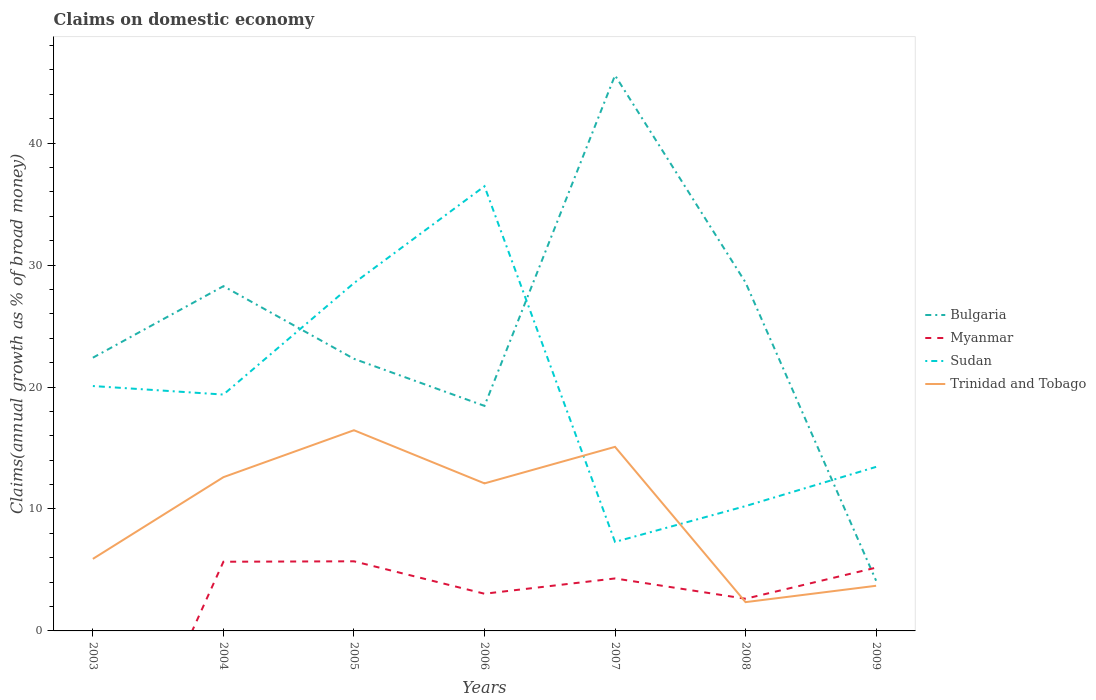Is the number of lines equal to the number of legend labels?
Provide a succinct answer. No. Across all years, what is the maximum percentage of broad money claimed on domestic economy in Bulgaria?
Your answer should be compact. 4.12. What is the total percentage of broad money claimed on domestic economy in Bulgaria in the graph?
Make the answer very short. 41.44. What is the difference between the highest and the second highest percentage of broad money claimed on domestic economy in Bulgaria?
Ensure brevity in your answer.  41.44. Is the percentage of broad money claimed on domestic economy in Sudan strictly greater than the percentage of broad money claimed on domestic economy in Myanmar over the years?
Your answer should be compact. No. How many lines are there?
Keep it short and to the point. 4. Does the graph contain any zero values?
Your answer should be compact. Yes. What is the title of the graph?
Provide a succinct answer. Claims on domestic economy. What is the label or title of the X-axis?
Provide a succinct answer. Years. What is the label or title of the Y-axis?
Offer a very short reply. Claims(annual growth as % of broad money). What is the Claims(annual growth as % of broad money) in Bulgaria in 2003?
Offer a terse response. 22.41. What is the Claims(annual growth as % of broad money) of Myanmar in 2003?
Make the answer very short. 0. What is the Claims(annual growth as % of broad money) of Sudan in 2003?
Your answer should be very brief. 20.08. What is the Claims(annual growth as % of broad money) of Trinidad and Tobago in 2003?
Keep it short and to the point. 5.91. What is the Claims(annual growth as % of broad money) in Bulgaria in 2004?
Ensure brevity in your answer.  28.27. What is the Claims(annual growth as % of broad money) of Myanmar in 2004?
Make the answer very short. 5.67. What is the Claims(annual growth as % of broad money) in Sudan in 2004?
Offer a terse response. 19.38. What is the Claims(annual growth as % of broad money) in Trinidad and Tobago in 2004?
Your answer should be compact. 12.61. What is the Claims(annual growth as % of broad money) in Bulgaria in 2005?
Your response must be concise. 22.32. What is the Claims(annual growth as % of broad money) of Myanmar in 2005?
Offer a terse response. 5.71. What is the Claims(annual growth as % of broad money) of Sudan in 2005?
Offer a very short reply. 28.52. What is the Claims(annual growth as % of broad money) of Trinidad and Tobago in 2005?
Your answer should be compact. 16.46. What is the Claims(annual growth as % of broad money) in Bulgaria in 2006?
Your response must be concise. 18.45. What is the Claims(annual growth as % of broad money) of Myanmar in 2006?
Provide a succinct answer. 3.05. What is the Claims(annual growth as % of broad money) in Sudan in 2006?
Provide a short and direct response. 36.47. What is the Claims(annual growth as % of broad money) of Trinidad and Tobago in 2006?
Offer a terse response. 12.1. What is the Claims(annual growth as % of broad money) of Bulgaria in 2007?
Offer a very short reply. 45.56. What is the Claims(annual growth as % of broad money) of Myanmar in 2007?
Ensure brevity in your answer.  4.3. What is the Claims(annual growth as % of broad money) of Sudan in 2007?
Give a very brief answer. 7.3. What is the Claims(annual growth as % of broad money) of Trinidad and Tobago in 2007?
Ensure brevity in your answer.  15.09. What is the Claims(annual growth as % of broad money) of Bulgaria in 2008?
Your answer should be very brief. 28.57. What is the Claims(annual growth as % of broad money) in Myanmar in 2008?
Your answer should be compact. 2.64. What is the Claims(annual growth as % of broad money) of Sudan in 2008?
Provide a short and direct response. 10.24. What is the Claims(annual growth as % of broad money) in Trinidad and Tobago in 2008?
Make the answer very short. 2.36. What is the Claims(annual growth as % of broad money) in Bulgaria in 2009?
Keep it short and to the point. 4.12. What is the Claims(annual growth as % of broad money) of Myanmar in 2009?
Provide a short and direct response. 5.19. What is the Claims(annual growth as % of broad money) in Sudan in 2009?
Make the answer very short. 13.45. What is the Claims(annual growth as % of broad money) of Trinidad and Tobago in 2009?
Ensure brevity in your answer.  3.7. Across all years, what is the maximum Claims(annual growth as % of broad money) in Bulgaria?
Your answer should be compact. 45.56. Across all years, what is the maximum Claims(annual growth as % of broad money) of Myanmar?
Offer a terse response. 5.71. Across all years, what is the maximum Claims(annual growth as % of broad money) of Sudan?
Your response must be concise. 36.47. Across all years, what is the maximum Claims(annual growth as % of broad money) in Trinidad and Tobago?
Give a very brief answer. 16.46. Across all years, what is the minimum Claims(annual growth as % of broad money) of Bulgaria?
Offer a terse response. 4.12. Across all years, what is the minimum Claims(annual growth as % of broad money) of Sudan?
Provide a succinct answer. 7.3. Across all years, what is the minimum Claims(annual growth as % of broad money) of Trinidad and Tobago?
Provide a short and direct response. 2.36. What is the total Claims(annual growth as % of broad money) in Bulgaria in the graph?
Ensure brevity in your answer.  169.7. What is the total Claims(annual growth as % of broad money) of Myanmar in the graph?
Provide a succinct answer. 26.56. What is the total Claims(annual growth as % of broad money) in Sudan in the graph?
Keep it short and to the point. 135.45. What is the total Claims(annual growth as % of broad money) of Trinidad and Tobago in the graph?
Your answer should be compact. 68.23. What is the difference between the Claims(annual growth as % of broad money) of Bulgaria in 2003 and that in 2004?
Offer a terse response. -5.87. What is the difference between the Claims(annual growth as % of broad money) of Sudan in 2003 and that in 2004?
Make the answer very short. 0.7. What is the difference between the Claims(annual growth as % of broad money) in Trinidad and Tobago in 2003 and that in 2004?
Provide a succinct answer. -6.7. What is the difference between the Claims(annual growth as % of broad money) in Bulgaria in 2003 and that in 2005?
Your answer should be compact. 0.09. What is the difference between the Claims(annual growth as % of broad money) in Sudan in 2003 and that in 2005?
Your answer should be very brief. -8.44. What is the difference between the Claims(annual growth as % of broad money) in Trinidad and Tobago in 2003 and that in 2005?
Ensure brevity in your answer.  -10.55. What is the difference between the Claims(annual growth as % of broad money) of Bulgaria in 2003 and that in 2006?
Keep it short and to the point. 3.95. What is the difference between the Claims(annual growth as % of broad money) of Sudan in 2003 and that in 2006?
Your answer should be compact. -16.38. What is the difference between the Claims(annual growth as % of broad money) of Trinidad and Tobago in 2003 and that in 2006?
Provide a succinct answer. -6.19. What is the difference between the Claims(annual growth as % of broad money) in Bulgaria in 2003 and that in 2007?
Offer a terse response. -23.15. What is the difference between the Claims(annual growth as % of broad money) of Sudan in 2003 and that in 2007?
Your answer should be very brief. 12.78. What is the difference between the Claims(annual growth as % of broad money) of Trinidad and Tobago in 2003 and that in 2007?
Offer a terse response. -9.19. What is the difference between the Claims(annual growth as % of broad money) of Bulgaria in 2003 and that in 2008?
Provide a short and direct response. -6.16. What is the difference between the Claims(annual growth as % of broad money) in Sudan in 2003 and that in 2008?
Offer a terse response. 9.84. What is the difference between the Claims(annual growth as % of broad money) of Trinidad and Tobago in 2003 and that in 2008?
Provide a succinct answer. 3.55. What is the difference between the Claims(annual growth as % of broad money) in Bulgaria in 2003 and that in 2009?
Make the answer very short. 18.29. What is the difference between the Claims(annual growth as % of broad money) of Sudan in 2003 and that in 2009?
Ensure brevity in your answer.  6.63. What is the difference between the Claims(annual growth as % of broad money) in Trinidad and Tobago in 2003 and that in 2009?
Keep it short and to the point. 2.2. What is the difference between the Claims(annual growth as % of broad money) of Bulgaria in 2004 and that in 2005?
Your answer should be compact. 5.96. What is the difference between the Claims(annual growth as % of broad money) of Myanmar in 2004 and that in 2005?
Provide a succinct answer. -0.04. What is the difference between the Claims(annual growth as % of broad money) of Sudan in 2004 and that in 2005?
Your answer should be compact. -9.14. What is the difference between the Claims(annual growth as % of broad money) in Trinidad and Tobago in 2004 and that in 2005?
Give a very brief answer. -3.85. What is the difference between the Claims(annual growth as % of broad money) in Bulgaria in 2004 and that in 2006?
Make the answer very short. 9.82. What is the difference between the Claims(annual growth as % of broad money) in Myanmar in 2004 and that in 2006?
Offer a terse response. 2.62. What is the difference between the Claims(annual growth as % of broad money) in Sudan in 2004 and that in 2006?
Your answer should be compact. -17.08. What is the difference between the Claims(annual growth as % of broad money) in Trinidad and Tobago in 2004 and that in 2006?
Your answer should be compact. 0.51. What is the difference between the Claims(annual growth as % of broad money) of Bulgaria in 2004 and that in 2007?
Provide a short and direct response. -17.29. What is the difference between the Claims(annual growth as % of broad money) in Myanmar in 2004 and that in 2007?
Provide a short and direct response. 1.37. What is the difference between the Claims(annual growth as % of broad money) of Sudan in 2004 and that in 2007?
Provide a succinct answer. 12.08. What is the difference between the Claims(annual growth as % of broad money) in Trinidad and Tobago in 2004 and that in 2007?
Offer a very short reply. -2.49. What is the difference between the Claims(annual growth as % of broad money) in Bulgaria in 2004 and that in 2008?
Offer a terse response. -0.3. What is the difference between the Claims(annual growth as % of broad money) in Myanmar in 2004 and that in 2008?
Ensure brevity in your answer.  3.03. What is the difference between the Claims(annual growth as % of broad money) of Sudan in 2004 and that in 2008?
Offer a very short reply. 9.15. What is the difference between the Claims(annual growth as % of broad money) of Trinidad and Tobago in 2004 and that in 2008?
Provide a succinct answer. 10.25. What is the difference between the Claims(annual growth as % of broad money) of Bulgaria in 2004 and that in 2009?
Offer a very short reply. 24.15. What is the difference between the Claims(annual growth as % of broad money) in Myanmar in 2004 and that in 2009?
Provide a short and direct response. 0.48. What is the difference between the Claims(annual growth as % of broad money) in Sudan in 2004 and that in 2009?
Provide a succinct answer. 5.93. What is the difference between the Claims(annual growth as % of broad money) in Trinidad and Tobago in 2004 and that in 2009?
Offer a terse response. 8.91. What is the difference between the Claims(annual growth as % of broad money) in Bulgaria in 2005 and that in 2006?
Your answer should be compact. 3.86. What is the difference between the Claims(annual growth as % of broad money) in Myanmar in 2005 and that in 2006?
Offer a terse response. 2.66. What is the difference between the Claims(annual growth as % of broad money) in Sudan in 2005 and that in 2006?
Give a very brief answer. -7.94. What is the difference between the Claims(annual growth as % of broad money) of Trinidad and Tobago in 2005 and that in 2006?
Your response must be concise. 4.36. What is the difference between the Claims(annual growth as % of broad money) in Bulgaria in 2005 and that in 2007?
Provide a short and direct response. -23.24. What is the difference between the Claims(annual growth as % of broad money) in Myanmar in 2005 and that in 2007?
Ensure brevity in your answer.  1.41. What is the difference between the Claims(annual growth as % of broad money) of Sudan in 2005 and that in 2007?
Ensure brevity in your answer.  21.23. What is the difference between the Claims(annual growth as % of broad money) in Trinidad and Tobago in 2005 and that in 2007?
Make the answer very short. 1.36. What is the difference between the Claims(annual growth as % of broad money) of Bulgaria in 2005 and that in 2008?
Offer a very short reply. -6.26. What is the difference between the Claims(annual growth as % of broad money) of Myanmar in 2005 and that in 2008?
Provide a short and direct response. 3.07. What is the difference between the Claims(annual growth as % of broad money) in Sudan in 2005 and that in 2008?
Offer a terse response. 18.29. What is the difference between the Claims(annual growth as % of broad money) in Trinidad and Tobago in 2005 and that in 2008?
Offer a very short reply. 14.1. What is the difference between the Claims(annual growth as % of broad money) in Bulgaria in 2005 and that in 2009?
Ensure brevity in your answer.  18.2. What is the difference between the Claims(annual growth as % of broad money) of Myanmar in 2005 and that in 2009?
Your answer should be compact. 0.52. What is the difference between the Claims(annual growth as % of broad money) in Sudan in 2005 and that in 2009?
Make the answer very short. 15.07. What is the difference between the Claims(annual growth as % of broad money) in Trinidad and Tobago in 2005 and that in 2009?
Your answer should be very brief. 12.75. What is the difference between the Claims(annual growth as % of broad money) of Bulgaria in 2006 and that in 2007?
Your answer should be compact. -27.11. What is the difference between the Claims(annual growth as % of broad money) of Myanmar in 2006 and that in 2007?
Provide a short and direct response. -1.25. What is the difference between the Claims(annual growth as % of broad money) of Sudan in 2006 and that in 2007?
Your response must be concise. 29.17. What is the difference between the Claims(annual growth as % of broad money) of Trinidad and Tobago in 2006 and that in 2007?
Provide a short and direct response. -3. What is the difference between the Claims(annual growth as % of broad money) in Bulgaria in 2006 and that in 2008?
Keep it short and to the point. -10.12. What is the difference between the Claims(annual growth as % of broad money) in Myanmar in 2006 and that in 2008?
Keep it short and to the point. 0.41. What is the difference between the Claims(annual growth as % of broad money) in Sudan in 2006 and that in 2008?
Offer a terse response. 26.23. What is the difference between the Claims(annual growth as % of broad money) in Trinidad and Tobago in 2006 and that in 2008?
Your answer should be compact. 9.74. What is the difference between the Claims(annual growth as % of broad money) in Bulgaria in 2006 and that in 2009?
Your response must be concise. 14.33. What is the difference between the Claims(annual growth as % of broad money) in Myanmar in 2006 and that in 2009?
Your response must be concise. -2.14. What is the difference between the Claims(annual growth as % of broad money) in Sudan in 2006 and that in 2009?
Your response must be concise. 23.01. What is the difference between the Claims(annual growth as % of broad money) of Trinidad and Tobago in 2006 and that in 2009?
Provide a short and direct response. 8.4. What is the difference between the Claims(annual growth as % of broad money) in Bulgaria in 2007 and that in 2008?
Offer a terse response. 16.99. What is the difference between the Claims(annual growth as % of broad money) in Myanmar in 2007 and that in 2008?
Your answer should be very brief. 1.66. What is the difference between the Claims(annual growth as % of broad money) of Sudan in 2007 and that in 2008?
Keep it short and to the point. -2.94. What is the difference between the Claims(annual growth as % of broad money) of Trinidad and Tobago in 2007 and that in 2008?
Keep it short and to the point. 12.73. What is the difference between the Claims(annual growth as % of broad money) in Bulgaria in 2007 and that in 2009?
Give a very brief answer. 41.44. What is the difference between the Claims(annual growth as % of broad money) of Myanmar in 2007 and that in 2009?
Your answer should be compact. -0.89. What is the difference between the Claims(annual growth as % of broad money) of Sudan in 2007 and that in 2009?
Give a very brief answer. -6.15. What is the difference between the Claims(annual growth as % of broad money) of Trinidad and Tobago in 2007 and that in 2009?
Your answer should be very brief. 11.39. What is the difference between the Claims(annual growth as % of broad money) of Bulgaria in 2008 and that in 2009?
Your response must be concise. 24.45. What is the difference between the Claims(annual growth as % of broad money) of Myanmar in 2008 and that in 2009?
Offer a very short reply. -2.55. What is the difference between the Claims(annual growth as % of broad money) of Sudan in 2008 and that in 2009?
Provide a short and direct response. -3.22. What is the difference between the Claims(annual growth as % of broad money) of Trinidad and Tobago in 2008 and that in 2009?
Offer a very short reply. -1.34. What is the difference between the Claims(annual growth as % of broad money) in Bulgaria in 2003 and the Claims(annual growth as % of broad money) in Myanmar in 2004?
Your answer should be very brief. 16.73. What is the difference between the Claims(annual growth as % of broad money) in Bulgaria in 2003 and the Claims(annual growth as % of broad money) in Sudan in 2004?
Make the answer very short. 3.02. What is the difference between the Claims(annual growth as % of broad money) in Bulgaria in 2003 and the Claims(annual growth as % of broad money) in Trinidad and Tobago in 2004?
Your response must be concise. 9.8. What is the difference between the Claims(annual growth as % of broad money) in Sudan in 2003 and the Claims(annual growth as % of broad money) in Trinidad and Tobago in 2004?
Your answer should be very brief. 7.47. What is the difference between the Claims(annual growth as % of broad money) in Bulgaria in 2003 and the Claims(annual growth as % of broad money) in Myanmar in 2005?
Provide a short and direct response. 16.7. What is the difference between the Claims(annual growth as % of broad money) of Bulgaria in 2003 and the Claims(annual growth as % of broad money) of Sudan in 2005?
Offer a very short reply. -6.12. What is the difference between the Claims(annual growth as % of broad money) in Bulgaria in 2003 and the Claims(annual growth as % of broad money) in Trinidad and Tobago in 2005?
Provide a short and direct response. 5.95. What is the difference between the Claims(annual growth as % of broad money) of Sudan in 2003 and the Claims(annual growth as % of broad money) of Trinidad and Tobago in 2005?
Your answer should be very brief. 3.62. What is the difference between the Claims(annual growth as % of broad money) in Bulgaria in 2003 and the Claims(annual growth as % of broad money) in Myanmar in 2006?
Make the answer very short. 19.36. What is the difference between the Claims(annual growth as % of broad money) in Bulgaria in 2003 and the Claims(annual growth as % of broad money) in Sudan in 2006?
Keep it short and to the point. -14.06. What is the difference between the Claims(annual growth as % of broad money) of Bulgaria in 2003 and the Claims(annual growth as % of broad money) of Trinidad and Tobago in 2006?
Your answer should be compact. 10.31. What is the difference between the Claims(annual growth as % of broad money) of Sudan in 2003 and the Claims(annual growth as % of broad money) of Trinidad and Tobago in 2006?
Your answer should be very brief. 7.98. What is the difference between the Claims(annual growth as % of broad money) of Bulgaria in 2003 and the Claims(annual growth as % of broad money) of Myanmar in 2007?
Give a very brief answer. 18.1. What is the difference between the Claims(annual growth as % of broad money) of Bulgaria in 2003 and the Claims(annual growth as % of broad money) of Sudan in 2007?
Offer a terse response. 15.11. What is the difference between the Claims(annual growth as % of broad money) of Bulgaria in 2003 and the Claims(annual growth as % of broad money) of Trinidad and Tobago in 2007?
Ensure brevity in your answer.  7.31. What is the difference between the Claims(annual growth as % of broad money) of Sudan in 2003 and the Claims(annual growth as % of broad money) of Trinidad and Tobago in 2007?
Provide a succinct answer. 4.99. What is the difference between the Claims(annual growth as % of broad money) of Bulgaria in 2003 and the Claims(annual growth as % of broad money) of Myanmar in 2008?
Give a very brief answer. 19.77. What is the difference between the Claims(annual growth as % of broad money) of Bulgaria in 2003 and the Claims(annual growth as % of broad money) of Sudan in 2008?
Keep it short and to the point. 12.17. What is the difference between the Claims(annual growth as % of broad money) in Bulgaria in 2003 and the Claims(annual growth as % of broad money) in Trinidad and Tobago in 2008?
Ensure brevity in your answer.  20.05. What is the difference between the Claims(annual growth as % of broad money) of Sudan in 2003 and the Claims(annual growth as % of broad money) of Trinidad and Tobago in 2008?
Offer a very short reply. 17.72. What is the difference between the Claims(annual growth as % of broad money) in Bulgaria in 2003 and the Claims(annual growth as % of broad money) in Myanmar in 2009?
Your response must be concise. 17.22. What is the difference between the Claims(annual growth as % of broad money) of Bulgaria in 2003 and the Claims(annual growth as % of broad money) of Sudan in 2009?
Ensure brevity in your answer.  8.95. What is the difference between the Claims(annual growth as % of broad money) of Bulgaria in 2003 and the Claims(annual growth as % of broad money) of Trinidad and Tobago in 2009?
Your answer should be very brief. 18.7. What is the difference between the Claims(annual growth as % of broad money) of Sudan in 2003 and the Claims(annual growth as % of broad money) of Trinidad and Tobago in 2009?
Give a very brief answer. 16.38. What is the difference between the Claims(annual growth as % of broad money) of Bulgaria in 2004 and the Claims(annual growth as % of broad money) of Myanmar in 2005?
Your response must be concise. 22.56. What is the difference between the Claims(annual growth as % of broad money) of Bulgaria in 2004 and the Claims(annual growth as % of broad money) of Sudan in 2005?
Provide a short and direct response. -0.25. What is the difference between the Claims(annual growth as % of broad money) of Bulgaria in 2004 and the Claims(annual growth as % of broad money) of Trinidad and Tobago in 2005?
Offer a terse response. 11.81. What is the difference between the Claims(annual growth as % of broad money) in Myanmar in 2004 and the Claims(annual growth as % of broad money) in Sudan in 2005?
Your response must be concise. -22.85. What is the difference between the Claims(annual growth as % of broad money) in Myanmar in 2004 and the Claims(annual growth as % of broad money) in Trinidad and Tobago in 2005?
Offer a terse response. -10.78. What is the difference between the Claims(annual growth as % of broad money) of Sudan in 2004 and the Claims(annual growth as % of broad money) of Trinidad and Tobago in 2005?
Offer a very short reply. 2.93. What is the difference between the Claims(annual growth as % of broad money) in Bulgaria in 2004 and the Claims(annual growth as % of broad money) in Myanmar in 2006?
Give a very brief answer. 25.22. What is the difference between the Claims(annual growth as % of broad money) in Bulgaria in 2004 and the Claims(annual growth as % of broad money) in Sudan in 2006?
Make the answer very short. -8.19. What is the difference between the Claims(annual growth as % of broad money) in Bulgaria in 2004 and the Claims(annual growth as % of broad money) in Trinidad and Tobago in 2006?
Give a very brief answer. 16.17. What is the difference between the Claims(annual growth as % of broad money) of Myanmar in 2004 and the Claims(annual growth as % of broad money) of Sudan in 2006?
Give a very brief answer. -30.79. What is the difference between the Claims(annual growth as % of broad money) in Myanmar in 2004 and the Claims(annual growth as % of broad money) in Trinidad and Tobago in 2006?
Provide a succinct answer. -6.43. What is the difference between the Claims(annual growth as % of broad money) in Sudan in 2004 and the Claims(annual growth as % of broad money) in Trinidad and Tobago in 2006?
Ensure brevity in your answer.  7.28. What is the difference between the Claims(annual growth as % of broad money) of Bulgaria in 2004 and the Claims(annual growth as % of broad money) of Myanmar in 2007?
Provide a succinct answer. 23.97. What is the difference between the Claims(annual growth as % of broad money) in Bulgaria in 2004 and the Claims(annual growth as % of broad money) in Sudan in 2007?
Your answer should be very brief. 20.97. What is the difference between the Claims(annual growth as % of broad money) in Bulgaria in 2004 and the Claims(annual growth as % of broad money) in Trinidad and Tobago in 2007?
Give a very brief answer. 13.18. What is the difference between the Claims(annual growth as % of broad money) in Myanmar in 2004 and the Claims(annual growth as % of broad money) in Sudan in 2007?
Give a very brief answer. -1.63. What is the difference between the Claims(annual growth as % of broad money) in Myanmar in 2004 and the Claims(annual growth as % of broad money) in Trinidad and Tobago in 2007?
Provide a succinct answer. -9.42. What is the difference between the Claims(annual growth as % of broad money) in Sudan in 2004 and the Claims(annual growth as % of broad money) in Trinidad and Tobago in 2007?
Give a very brief answer. 4.29. What is the difference between the Claims(annual growth as % of broad money) of Bulgaria in 2004 and the Claims(annual growth as % of broad money) of Myanmar in 2008?
Give a very brief answer. 25.63. What is the difference between the Claims(annual growth as % of broad money) in Bulgaria in 2004 and the Claims(annual growth as % of broad money) in Sudan in 2008?
Offer a terse response. 18.03. What is the difference between the Claims(annual growth as % of broad money) of Bulgaria in 2004 and the Claims(annual growth as % of broad money) of Trinidad and Tobago in 2008?
Offer a very short reply. 25.91. What is the difference between the Claims(annual growth as % of broad money) in Myanmar in 2004 and the Claims(annual growth as % of broad money) in Sudan in 2008?
Your answer should be very brief. -4.56. What is the difference between the Claims(annual growth as % of broad money) of Myanmar in 2004 and the Claims(annual growth as % of broad money) of Trinidad and Tobago in 2008?
Ensure brevity in your answer.  3.31. What is the difference between the Claims(annual growth as % of broad money) in Sudan in 2004 and the Claims(annual growth as % of broad money) in Trinidad and Tobago in 2008?
Your answer should be very brief. 17.02. What is the difference between the Claims(annual growth as % of broad money) in Bulgaria in 2004 and the Claims(annual growth as % of broad money) in Myanmar in 2009?
Ensure brevity in your answer.  23.08. What is the difference between the Claims(annual growth as % of broad money) of Bulgaria in 2004 and the Claims(annual growth as % of broad money) of Sudan in 2009?
Ensure brevity in your answer.  14.82. What is the difference between the Claims(annual growth as % of broad money) in Bulgaria in 2004 and the Claims(annual growth as % of broad money) in Trinidad and Tobago in 2009?
Make the answer very short. 24.57. What is the difference between the Claims(annual growth as % of broad money) in Myanmar in 2004 and the Claims(annual growth as % of broad money) in Sudan in 2009?
Offer a very short reply. -7.78. What is the difference between the Claims(annual growth as % of broad money) in Myanmar in 2004 and the Claims(annual growth as % of broad money) in Trinidad and Tobago in 2009?
Ensure brevity in your answer.  1.97. What is the difference between the Claims(annual growth as % of broad money) in Sudan in 2004 and the Claims(annual growth as % of broad money) in Trinidad and Tobago in 2009?
Your answer should be very brief. 15.68. What is the difference between the Claims(annual growth as % of broad money) of Bulgaria in 2005 and the Claims(annual growth as % of broad money) of Myanmar in 2006?
Provide a succinct answer. 19.27. What is the difference between the Claims(annual growth as % of broad money) in Bulgaria in 2005 and the Claims(annual growth as % of broad money) in Sudan in 2006?
Provide a succinct answer. -14.15. What is the difference between the Claims(annual growth as % of broad money) in Bulgaria in 2005 and the Claims(annual growth as % of broad money) in Trinidad and Tobago in 2006?
Provide a succinct answer. 10.22. What is the difference between the Claims(annual growth as % of broad money) of Myanmar in 2005 and the Claims(annual growth as % of broad money) of Sudan in 2006?
Offer a very short reply. -30.76. What is the difference between the Claims(annual growth as % of broad money) of Myanmar in 2005 and the Claims(annual growth as % of broad money) of Trinidad and Tobago in 2006?
Give a very brief answer. -6.39. What is the difference between the Claims(annual growth as % of broad money) in Sudan in 2005 and the Claims(annual growth as % of broad money) in Trinidad and Tobago in 2006?
Provide a succinct answer. 16.43. What is the difference between the Claims(annual growth as % of broad money) in Bulgaria in 2005 and the Claims(annual growth as % of broad money) in Myanmar in 2007?
Give a very brief answer. 18.01. What is the difference between the Claims(annual growth as % of broad money) of Bulgaria in 2005 and the Claims(annual growth as % of broad money) of Sudan in 2007?
Your answer should be very brief. 15.02. What is the difference between the Claims(annual growth as % of broad money) in Bulgaria in 2005 and the Claims(annual growth as % of broad money) in Trinidad and Tobago in 2007?
Your response must be concise. 7.22. What is the difference between the Claims(annual growth as % of broad money) of Myanmar in 2005 and the Claims(annual growth as % of broad money) of Sudan in 2007?
Offer a terse response. -1.59. What is the difference between the Claims(annual growth as % of broad money) in Myanmar in 2005 and the Claims(annual growth as % of broad money) in Trinidad and Tobago in 2007?
Give a very brief answer. -9.39. What is the difference between the Claims(annual growth as % of broad money) in Sudan in 2005 and the Claims(annual growth as % of broad money) in Trinidad and Tobago in 2007?
Your answer should be very brief. 13.43. What is the difference between the Claims(annual growth as % of broad money) of Bulgaria in 2005 and the Claims(annual growth as % of broad money) of Myanmar in 2008?
Offer a terse response. 19.68. What is the difference between the Claims(annual growth as % of broad money) of Bulgaria in 2005 and the Claims(annual growth as % of broad money) of Sudan in 2008?
Offer a terse response. 12.08. What is the difference between the Claims(annual growth as % of broad money) of Bulgaria in 2005 and the Claims(annual growth as % of broad money) of Trinidad and Tobago in 2008?
Your answer should be compact. 19.95. What is the difference between the Claims(annual growth as % of broad money) in Myanmar in 2005 and the Claims(annual growth as % of broad money) in Sudan in 2008?
Offer a terse response. -4.53. What is the difference between the Claims(annual growth as % of broad money) of Myanmar in 2005 and the Claims(annual growth as % of broad money) of Trinidad and Tobago in 2008?
Provide a succinct answer. 3.35. What is the difference between the Claims(annual growth as % of broad money) in Sudan in 2005 and the Claims(annual growth as % of broad money) in Trinidad and Tobago in 2008?
Your answer should be very brief. 26.16. What is the difference between the Claims(annual growth as % of broad money) of Bulgaria in 2005 and the Claims(annual growth as % of broad money) of Myanmar in 2009?
Your answer should be compact. 17.13. What is the difference between the Claims(annual growth as % of broad money) in Bulgaria in 2005 and the Claims(annual growth as % of broad money) in Sudan in 2009?
Your answer should be very brief. 8.86. What is the difference between the Claims(annual growth as % of broad money) of Bulgaria in 2005 and the Claims(annual growth as % of broad money) of Trinidad and Tobago in 2009?
Keep it short and to the point. 18.61. What is the difference between the Claims(annual growth as % of broad money) of Myanmar in 2005 and the Claims(annual growth as % of broad money) of Sudan in 2009?
Give a very brief answer. -7.74. What is the difference between the Claims(annual growth as % of broad money) in Myanmar in 2005 and the Claims(annual growth as % of broad money) in Trinidad and Tobago in 2009?
Give a very brief answer. 2.01. What is the difference between the Claims(annual growth as % of broad money) of Sudan in 2005 and the Claims(annual growth as % of broad money) of Trinidad and Tobago in 2009?
Offer a terse response. 24.82. What is the difference between the Claims(annual growth as % of broad money) in Bulgaria in 2006 and the Claims(annual growth as % of broad money) in Myanmar in 2007?
Your answer should be compact. 14.15. What is the difference between the Claims(annual growth as % of broad money) of Bulgaria in 2006 and the Claims(annual growth as % of broad money) of Sudan in 2007?
Provide a short and direct response. 11.15. What is the difference between the Claims(annual growth as % of broad money) in Bulgaria in 2006 and the Claims(annual growth as % of broad money) in Trinidad and Tobago in 2007?
Offer a very short reply. 3.36. What is the difference between the Claims(annual growth as % of broad money) of Myanmar in 2006 and the Claims(annual growth as % of broad money) of Sudan in 2007?
Keep it short and to the point. -4.25. What is the difference between the Claims(annual growth as % of broad money) in Myanmar in 2006 and the Claims(annual growth as % of broad money) in Trinidad and Tobago in 2007?
Ensure brevity in your answer.  -12.04. What is the difference between the Claims(annual growth as % of broad money) in Sudan in 2006 and the Claims(annual growth as % of broad money) in Trinidad and Tobago in 2007?
Your answer should be very brief. 21.37. What is the difference between the Claims(annual growth as % of broad money) in Bulgaria in 2006 and the Claims(annual growth as % of broad money) in Myanmar in 2008?
Offer a very short reply. 15.81. What is the difference between the Claims(annual growth as % of broad money) of Bulgaria in 2006 and the Claims(annual growth as % of broad money) of Sudan in 2008?
Keep it short and to the point. 8.22. What is the difference between the Claims(annual growth as % of broad money) in Bulgaria in 2006 and the Claims(annual growth as % of broad money) in Trinidad and Tobago in 2008?
Provide a succinct answer. 16.09. What is the difference between the Claims(annual growth as % of broad money) of Myanmar in 2006 and the Claims(annual growth as % of broad money) of Sudan in 2008?
Make the answer very short. -7.19. What is the difference between the Claims(annual growth as % of broad money) in Myanmar in 2006 and the Claims(annual growth as % of broad money) in Trinidad and Tobago in 2008?
Offer a terse response. 0.69. What is the difference between the Claims(annual growth as % of broad money) of Sudan in 2006 and the Claims(annual growth as % of broad money) of Trinidad and Tobago in 2008?
Your answer should be compact. 34.11. What is the difference between the Claims(annual growth as % of broad money) in Bulgaria in 2006 and the Claims(annual growth as % of broad money) in Myanmar in 2009?
Provide a succinct answer. 13.27. What is the difference between the Claims(annual growth as % of broad money) of Bulgaria in 2006 and the Claims(annual growth as % of broad money) of Sudan in 2009?
Offer a very short reply. 5. What is the difference between the Claims(annual growth as % of broad money) of Bulgaria in 2006 and the Claims(annual growth as % of broad money) of Trinidad and Tobago in 2009?
Keep it short and to the point. 14.75. What is the difference between the Claims(annual growth as % of broad money) in Myanmar in 2006 and the Claims(annual growth as % of broad money) in Sudan in 2009?
Give a very brief answer. -10.4. What is the difference between the Claims(annual growth as % of broad money) in Myanmar in 2006 and the Claims(annual growth as % of broad money) in Trinidad and Tobago in 2009?
Keep it short and to the point. -0.65. What is the difference between the Claims(annual growth as % of broad money) in Sudan in 2006 and the Claims(annual growth as % of broad money) in Trinidad and Tobago in 2009?
Your response must be concise. 32.76. What is the difference between the Claims(annual growth as % of broad money) of Bulgaria in 2007 and the Claims(annual growth as % of broad money) of Myanmar in 2008?
Make the answer very short. 42.92. What is the difference between the Claims(annual growth as % of broad money) in Bulgaria in 2007 and the Claims(annual growth as % of broad money) in Sudan in 2008?
Ensure brevity in your answer.  35.32. What is the difference between the Claims(annual growth as % of broad money) of Bulgaria in 2007 and the Claims(annual growth as % of broad money) of Trinidad and Tobago in 2008?
Provide a succinct answer. 43.2. What is the difference between the Claims(annual growth as % of broad money) of Myanmar in 2007 and the Claims(annual growth as % of broad money) of Sudan in 2008?
Your answer should be compact. -5.93. What is the difference between the Claims(annual growth as % of broad money) of Myanmar in 2007 and the Claims(annual growth as % of broad money) of Trinidad and Tobago in 2008?
Provide a succinct answer. 1.94. What is the difference between the Claims(annual growth as % of broad money) in Sudan in 2007 and the Claims(annual growth as % of broad money) in Trinidad and Tobago in 2008?
Keep it short and to the point. 4.94. What is the difference between the Claims(annual growth as % of broad money) of Bulgaria in 2007 and the Claims(annual growth as % of broad money) of Myanmar in 2009?
Provide a succinct answer. 40.37. What is the difference between the Claims(annual growth as % of broad money) of Bulgaria in 2007 and the Claims(annual growth as % of broad money) of Sudan in 2009?
Give a very brief answer. 32.11. What is the difference between the Claims(annual growth as % of broad money) in Bulgaria in 2007 and the Claims(annual growth as % of broad money) in Trinidad and Tobago in 2009?
Your answer should be very brief. 41.86. What is the difference between the Claims(annual growth as % of broad money) of Myanmar in 2007 and the Claims(annual growth as % of broad money) of Sudan in 2009?
Ensure brevity in your answer.  -9.15. What is the difference between the Claims(annual growth as % of broad money) in Myanmar in 2007 and the Claims(annual growth as % of broad money) in Trinidad and Tobago in 2009?
Your answer should be compact. 0.6. What is the difference between the Claims(annual growth as % of broad money) in Sudan in 2007 and the Claims(annual growth as % of broad money) in Trinidad and Tobago in 2009?
Offer a very short reply. 3.6. What is the difference between the Claims(annual growth as % of broad money) of Bulgaria in 2008 and the Claims(annual growth as % of broad money) of Myanmar in 2009?
Make the answer very short. 23.38. What is the difference between the Claims(annual growth as % of broad money) of Bulgaria in 2008 and the Claims(annual growth as % of broad money) of Sudan in 2009?
Give a very brief answer. 15.12. What is the difference between the Claims(annual growth as % of broad money) of Bulgaria in 2008 and the Claims(annual growth as % of broad money) of Trinidad and Tobago in 2009?
Make the answer very short. 24.87. What is the difference between the Claims(annual growth as % of broad money) in Myanmar in 2008 and the Claims(annual growth as % of broad money) in Sudan in 2009?
Give a very brief answer. -10.81. What is the difference between the Claims(annual growth as % of broad money) of Myanmar in 2008 and the Claims(annual growth as % of broad money) of Trinidad and Tobago in 2009?
Your answer should be very brief. -1.06. What is the difference between the Claims(annual growth as % of broad money) in Sudan in 2008 and the Claims(annual growth as % of broad money) in Trinidad and Tobago in 2009?
Your answer should be compact. 6.53. What is the average Claims(annual growth as % of broad money) in Bulgaria per year?
Your response must be concise. 24.24. What is the average Claims(annual growth as % of broad money) of Myanmar per year?
Offer a very short reply. 3.79. What is the average Claims(annual growth as % of broad money) in Sudan per year?
Your answer should be very brief. 19.35. What is the average Claims(annual growth as % of broad money) of Trinidad and Tobago per year?
Offer a terse response. 9.75. In the year 2003, what is the difference between the Claims(annual growth as % of broad money) in Bulgaria and Claims(annual growth as % of broad money) in Sudan?
Your response must be concise. 2.32. In the year 2003, what is the difference between the Claims(annual growth as % of broad money) in Bulgaria and Claims(annual growth as % of broad money) in Trinidad and Tobago?
Your answer should be compact. 16.5. In the year 2003, what is the difference between the Claims(annual growth as % of broad money) in Sudan and Claims(annual growth as % of broad money) in Trinidad and Tobago?
Offer a terse response. 14.17. In the year 2004, what is the difference between the Claims(annual growth as % of broad money) of Bulgaria and Claims(annual growth as % of broad money) of Myanmar?
Give a very brief answer. 22.6. In the year 2004, what is the difference between the Claims(annual growth as % of broad money) of Bulgaria and Claims(annual growth as % of broad money) of Sudan?
Offer a very short reply. 8.89. In the year 2004, what is the difference between the Claims(annual growth as % of broad money) of Bulgaria and Claims(annual growth as % of broad money) of Trinidad and Tobago?
Make the answer very short. 15.66. In the year 2004, what is the difference between the Claims(annual growth as % of broad money) of Myanmar and Claims(annual growth as % of broad money) of Sudan?
Provide a short and direct response. -13.71. In the year 2004, what is the difference between the Claims(annual growth as % of broad money) in Myanmar and Claims(annual growth as % of broad money) in Trinidad and Tobago?
Your response must be concise. -6.93. In the year 2004, what is the difference between the Claims(annual growth as % of broad money) in Sudan and Claims(annual growth as % of broad money) in Trinidad and Tobago?
Provide a succinct answer. 6.77. In the year 2005, what is the difference between the Claims(annual growth as % of broad money) of Bulgaria and Claims(annual growth as % of broad money) of Myanmar?
Offer a terse response. 16.61. In the year 2005, what is the difference between the Claims(annual growth as % of broad money) of Bulgaria and Claims(annual growth as % of broad money) of Sudan?
Offer a terse response. -6.21. In the year 2005, what is the difference between the Claims(annual growth as % of broad money) in Bulgaria and Claims(annual growth as % of broad money) in Trinidad and Tobago?
Your answer should be compact. 5.86. In the year 2005, what is the difference between the Claims(annual growth as % of broad money) in Myanmar and Claims(annual growth as % of broad money) in Sudan?
Ensure brevity in your answer.  -22.82. In the year 2005, what is the difference between the Claims(annual growth as % of broad money) of Myanmar and Claims(annual growth as % of broad money) of Trinidad and Tobago?
Offer a very short reply. -10.75. In the year 2005, what is the difference between the Claims(annual growth as % of broad money) of Sudan and Claims(annual growth as % of broad money) of Trinidad and Tobago?
Offer a terse response. 12.07. In the year 2006, what is the difference between the Claims(annual growth as % of broad money) of Bulgaria and Claims(annual growth as % of broad money) of Myanmar?
Your answer should be compact. 15.4. In the year 2006, what is the difference between the Claims(annual growth as % of broad money) of Bulgaria and Claims(annual growth as % of broad money) of Sudan?
Provide a short and direct response. -18.01. In the year 2006, what is the difference between the Claims(annual growth as % of broad money) in Bulgaria and Claims(annual growth as % of broad money) in Trinidad and Tobago?
Your response must be concise. 6.36. In the year 2006, what is the difference between the Claims(annual growth as % of broad money) of Myanmar and Claims(annual growth as % of broad money) of Sudan?
Ensure brevity in your answer.  -33.42. In the year 2006, what is the difference between the Claims(annual growth as % of broad money) of Myanmar and Claims(annual growth as % of broad money) of Trinidad and Tobago?
Keep it short and to the point. -9.05. In the year 2006, what is the difference between the Claims(annual growth as % of broad money) of Sudan and Claims(annual growth as % of broad money) of Trinidad and Tobago?
Give a very brief answer. 24.37. In the year 2007, what is the difference between the Claims(annual growth as % of broad money) of Bulgaria and Claims(annual growth as % of broad money) of Myanmar?
Your response must be concise. 41.26. In the year 2007, what is the difference between the Claims(annual growth as % of broad money) of Bulgaria and Claims(annual growth as % of broad money) of Sudan?
Your response must be concise. 38.26. In the year 2007, what is the difference between the Claims(annual growth as % of broad money) of Bulgaria and Claims(annual growth as % of broad money) of Trinidad and Tobago?
Make the answer very short. 30.46. In the year 2007, what is the difference between the Claims(annual growth as % of broad money) of Myanmar and Claims(annual growth as % of broad money) of Sudan?
Provide a short and direct response. -3. In the year 2007, what is the difference between the Claims(annual growth as % of broad money) of Myanmar and Claims(annual growth as % of broad money) of Trinidad and Tobago?
Provide a succinct answer. -10.79. In the year 2007, what is the difference between the Claims(annual growth as % of broad money) in Sudan and Claims(annual growth as % of broad money) in Trinidad and Tobago?
Ensure brevity in your answer.  -7.8. In the year 2008, what is the difference between the Claims(annual growth as % of broad money) in Bulgaria and Claims(annual growth as % of broad money) in Myanmar?
Your answer should be compact. 25.93. In the year 2008, what is the difference between the Claims(annual growth as % of broad money) of Bulgaria and Claims(annual growth as % of broad money) of Sudan?
Your answer should be very brief. 18.33. In the year 2008, what is the difference between the Claims(annual growth as % of broad money) of Bulgaria and Claims(annual growth as % of broad money) of Trinidad and Tobago?
Provide a short and direct response. 26.21. In the year 2008, what is the difference between the Claims(annual growth as % of broad money) in Myanmar and Claims(annual growth as % of broad money) in Sudan?
Keep it short and to the point. -7.6. In the year 2008, what is the difference between the Claims(annual growth as % of broad money) of Myanmar and Claims(annual growth as % of broad money) of Trinidad and Tobago?
Your answer should be compact. 0.28. In the year 2008, what is the difference between the Claims(annual growth as % of broad money) of Sudan and Claims(annual growth as % of broad money) of Trinidad and Tobago?
Your response must be concise. 7.88. In the year 2009, what is the difference between the Claims(annual growth as % of broad money) in Bulgaria and Claims(annual growth as % of broad money) in Myanmar?
Make the answer very short. -1.07. In the year 2009, what is the difference between the Claims(annual growth as % of broad money) in Bulgaria and Claims(annual growth as % of broad money) in Sudan?
Make the answer very short. -9.33. In the year 2009, what is the difference between the Claims(annual growth as % of broad money) in Bulgaria and Claims(annual growth as % of broad money) in Trinidad and Tobago?
Your answer should be very brief. 0.42. In the year 2009, what is the difference between the Claims(annual growth as % of broad money) in Myanmar and Claims(annual growth as % of broad money) in Sudan?
Your response must be concise. -8.26. In the year 2009, what is the difference between the Claims(annual growth as % of broad money) of Myanmar and Claims(annual growth as % of broad money) of Trinidad and Tobago?
Make the answer very short. 1.49. In the year 2009, what is the difference between the Claims(annual growth as % of broad money) of Sudan and Claims(annual growth as % of broad money) of Trinidad and Tobago?
Your answer should be compact. 9.75. What is the ratio of the Claims(annual growth as % of broad money) in Bulgaria in 2003 to that in 2004?
Give a very brief answer. 0.79. What is the ratio of the Claims(annual growth as % of broad money) in Sudan in 2003 to that in 2004?
Provide a succinct answer. 1.04. What is the ratio of the Claims(annual growth as % of broad money) in Trinidad and Tobago in 2003 to that in 2004?
Make the answer very short. 0.47. What is the ratio of the Claims(annual growth as % of broad money) of Sudan in 2003 to that in 2005?
Offer a very short reply. 0.7. What is the ratio of the Claims(annual growth as % of broad money) of Trinidad and Tobago in 2003 to that in 2005?
Keep it short and to the point. 0.36. What is the ratio of the Claims(annual growth as % of broad money) in Bulgaria in 2003 to that in 2006?
Ensure brevity in your answer.  1.21. What is the ratio of the Claims(annual growth as % of broad money) in Sudan in 2003 to that in 2006?
Provide a succinct answer. 0.55. What is the ratio of the Claims(annual growth as % of broad money) of Trinidad and Tobago in 2003 to that in 2006?
Your answer should be compact. 0.49. What is the ratio of the Claims(annual growth as % of broad money) in Bulgaria in 2003 to that in 2007?
Your response must be concise. 0.49. What is the ratio of the Claims(annual growth as % of broad money) in Sudan in 2003 to that in 2007?
Provide a short and direct response. 2.75. What is the ratio of the Claims(annual growth as % of broad money) in Trinidad and Tobago in 2003 to that in 2007?
Ensure brevity in your answer.  0.39. What is the ratio of the Claims(annual growth as % of broad money) in Bulgaria in 2003 to that in 2008?
Your response must be concise. 0.78. What is the ratio of the Claims(annual growth as % of broad money) of Sudan in 2003 to that in 2008?
Provide a short and direct response. 1.96. What is the ratio of the Claims(annual growth as % of broad money) of Trinidad and Tobago in 2003 to that in 2008?
Provide a short and direct response. 2.5. What is the ratio of the Claims(annual growth as % of broad money) of Bulgaria in 2003 to that in 2009?
Keep it short and to the point. 5.44. What is the ratio of the Claims(annual growth as % of broad money) in Sudan in 2003 to that in 2009?
Ensure brevity in your answer.  1.49. What is the ratio of the Claims(annual growth as % of broad money) of Trinidad and Tobago in 2003 to that in 2009?
Your response must be concise. 1.6. What is the ratio of the Claims(annual growth as % of broad money) of Bulgaria in 2004 to that in 2005?
Give a very brief answer. 1.27. What is the ratio of the Claims(annual growth as % of broad money) of Myanmar in 2004 to that in 2005?
Provide a succinct answer. 0.99. What is the ratio of the Claims(annual growth as % of broad money) in Sudan in 2004 to that in 2005?
Your answer should be compact. 0.68. What is the ratio of the Claims(annual growth as % of broad money) of Trinidad and Tobago in 2004 to that in 2005?
Provide a succinct answer. 0.77. What is the ratio of the Claims(annual growth as % of broad money) of Bulgaria in 2004 to that in 2006?
Offer a terse response. 1.53. What is the ratio of the Claims(annual growth as % of broad money) in Myanmar in 2004 to that in 2006?
Offer a very short reply. 1.86. What is the ratio of the Claims(annual growth as % of broad money) of Sudan in 2004 to that in 2006?
Keep it short and to the point. 0.53. What is the ratio of the Claims(annual growth as % of broad money) of Trinidad and Tobago in 2004 to that in 2006?
Keep it short and to the point. 1.04. What is the ratio of the Claims(annual growth as % of broad money) in Bulgaria in 2004 to that in 2007?
Offer a very short reply. 0.62. What is the ratio of the Claims(annual growth as % of broad money) of Myanmar in 2004 to that in 2007?
Give a very brief answer. 1.32. What is the ratio of the Claims(annual growth as % of broad money) of Sudan in 2004 to that in 2007?
Offer a terse response. 2.66. What is the ratio of the Claims(annual growth as % of broad money) of Trinidad and Tobago in 2004 to that in 2007?
Make the answer very short. 0.84. What is the ratio of the Claims(annual growth as % of broad money) of Bulgaria in 2004 to that in 2008?
Your response must be concise. 0.99. What is the ratio of the Claims(annual growth as % of broad money) of Myanmar in 2004 to that in 2008?
Offer a very short reply. 2.15. What is the ratio of the Claims(annual growth as % of broad money) in Sudan in 2004 to that in 2008?
Make the answer very short. 1.89. What is the ratio of the Claims(annual growth as % of broad money) in Trinidad and Tobago in 2004 to that in 2008?
Your answer should be compact. 5.34. What is the ratio of the Claims(annual growth as % of broad money) in Bulgaria in 2004 to that in 2009?
Your response must be concise. 6.86. What is the ratio of the Claims(annual growth as % of broad money) in Myanmar in 2004 to that in 2009?
Your answer should be compact. 1.09. What is the ratio of the Claims(annual growth as % of broad money) in Sudan in 2004 to that in 2009?
Keep it short and to the point. 1.44. What is the ratio of the Claims(annual growth as % of broad money) of Trinidad and Tobago in 2004 to that in 2009?
Offer a terse response. 3.4. What is the ratio of the Claims(annual growth as % of broad money) of Bulgaria in 2005 to that in 2006?
Offer a very short reply. 1.21. What is the ratio of the Claims(annual growth as % of broad money) of Myanmar in 2005 to that in 2006?
Provide a succinct answer. 1.87. What is the ratio of the Claims(annual growth as % of broad money) in Sudan in 2005 to that in 2006?
Your answer should be very brief. 0.78. What is the ratio of the Claims(annual growth as % of broad money) in Trinidad and Tobago in 2005 to that in 2006?
Your answer should be compact. 1.36. What is the ratio of the Claims(annual growth as % of broad money) of Bulgaria in 2005 to that in 2007?
Your answer should be compact. 0.49. What is the ratio of the Claims(annual growth as % of broad money) in Myanmar in 2005 to that in 2007?
Your answer should be compact. 1.33. What is the ratio of the Claims(annual growth as % of broad money) in Sudan in 2005 to that in 2007?
Provide a short and direct response. 3.91. What is the ratio of the Claims(annual growth as % of broad money) of Trinidad and Tobago in 2005 to that in 2007?
Your answer should be very brief. 1.09. What is the ratio of the Claims(annual growth as % of broad money) of Bulgaria in 2005 to that in 2008?
Your answer should be compact. 0.78. What is the ratio of the Claims(annual growth as % of broad money) in Myanmar in 2005 to that in 2008?
Your answer should be very brief. 2.16. What is the ratio of the Claims(annual growth as % of broad money) in Sudan in 2005 to that in 2008?
Your answer should be very brief. 2.79. What is the ratio of the Claims(annual growth as % of broad money) in Trinidad and Tobago in 2005 to that in 2008?
Provide a succinct answer. 6.97. What is the ratio of the Claims(annual growth as % of broad money) in Bulgaria in 2005 to that in 2009?
Offer a terse response. 5.42. What is the ratio of the Claims(annual growth as % of broad money) of Myanmar in 2005 to that in 2009?
Make the answer very short. 1.1. What is the ratio of the Claims(annual growth as % of broad money) of Sudan in 2005 to that in 2009?
Provide a succinct answer. 2.12. What is the ratio of the Claims(annual growth as % of broad money) of Trinidad and Tobago in 2005 to that in 2009?
Provide a short and direct response. 4.44. What is the ratio of the Claims(annual growth as % of broad money) of Bulgaria in 2006 to that in 2007?
Offer a terse response. 0.41. What is the ratio of the Claims(annual growth as % of broad money) in Myanmar in 2006 to that in 2007?
Provide a succinct answer. 0.71. What is the ratio of the Claims(annual growth as % of broad money) in Sudan in 2006 to that in 2007?
Keep it short and to the point. 5. What is the ratio of the Claims(annual growth as % of broad money) of Trinidad and Tobago in 2006 to that in 2007?
Give a very brief answer. 0.8. What is the ratio of the Claims(annual growth as % of broad money) in Bulgaria in 2006 to that in 2008?
Your answer should be compact. 0.65. What is the ratio of the Claims(annual growth as % of broad money) of Myanmar in 2006 to that in 2008?
Give a very brief answer. 1.16. What is the ratio of the Claims(annual growth as % of broad money) in Sudan in 2006 to that in 2008?
Your answer should be very brief. 3.56. What is the ratio of the Claims(annual growth as % of broad money) of Trinidad and Tobago in 2006 to that in 2008?
Provide a succinct answer. 5.13. What is the ratio of the Claims(annual growth as % of broad money) of Bulgaria in 2006 to that in 2009?
Keep it short and to the point. 4.48. What is the ratio of the Claims(annual growth as % of broad money) of Myanmar in 2006 to that in 2009?
Your answer should be very brief. 0.59. What is the ratio of the Claims(annual growth as % of broad money) in Sudan in 2006 to that in 2009?
Your response must be concise. 2.71. What is the ratio of the Claims(annual growth as % of broad money) in Trinidad and Tobago in 2006 to that in 2009?
Offer a terse response. 3.27. What is the ratio of the Claims(annual growth as % of broad money) of Bulgaria in 2007 to that in 2008?
Provide a succinct answer. 1.59. What is the ratio of the Claims(annual growth as % of broad money) in Myanmar in 2007 to that in 2008?
Provide a succinct answer. 1.63. What is the ratio of the Claims(annual growth as % of broad money) in Sudan in 2007 to that in 2008?
Ensure brevity in your answer.  0.71. What is the ratio of the Claims(annual growth as % of broad money) of Trinidad and Tobago in 2007 to that in 2008?
Your response must be concise. 6.4. What is the ratio of the Claims(annual growth as % of broad money) in Bulgaria in 2007 to that in 2009?
Give a very brief answer. 11.06. What is the ratio of the Claims(annual growth as % of broad money) of Myanmar in 2007 to that in 2009?
Offer a very short reply. 0.83. What is the ratio of the Claims(annual growth as % of broad money) of Sudan in 2007 to that in 2009?
Your answer should be very brief. 0.54. What is the ratio of the Claims(annual growth as % of broad money) of Trinidad and Tobago in 2007 to that in 2009?
Your response must be concise. 4.08. What is the ratio of the Claims(annual growth as % of broad money) in Bulgaria in 2008 to that in 2009?
Ensure brevity in your answer.  6.94. What is the ratio of the Claims(annual growth as % of broad money) of Myanmar in 2008 to that in 2009?
Offer a very short reply. 0.51. What is the ratio of the Claims(annual growth as % of broad money) in Sudan in 2008 to that in 2009?
Your answer should be very brief. 0.76. What is the ratio of the Claims(annual growth as % of broad money) of Trinidad and Tobago in 2008 to that in 2009?
Provide a short and direct response. 0.64. What is the difference between the highest and the second highest Claims(annual growth as % of broad money) of Bulgaria?
Offer a very short reply. 16.99. What is the difference between the highest and the second highest Claims(annual growth as % of broad money) in Myanmar?
Your response must be concise. 0.04. What is the difference between the highest and the second highest Claims(annual growth as % of broad money) in Sudan?
Offer a very short reply. 7.94. What is the difference between the highest and the second highest Claims(annual growth as % of broad money) in Trinidad and Tobago?
Offer a very short reply. 1.36. What is the difference between the highest and the lowest Claims(annual growth as % of broad money) of Bulgaria?
Your answer should be very brief. 41.44. What is the difference between the highest and the lowest Claims(annual growth as % of broad money) in Myanmar?
Your answer should be compact. 5.71. What is the difference between the highest and the lowest Claims(annual growth as % of broad money) of Sudan?
Your answer should be very brief. 29.17. What is the difference between the highest and the lowest Claims(annual growth as % of broad money) of Trinidad and Tobago?
Your answer should be compact. 14.1. 